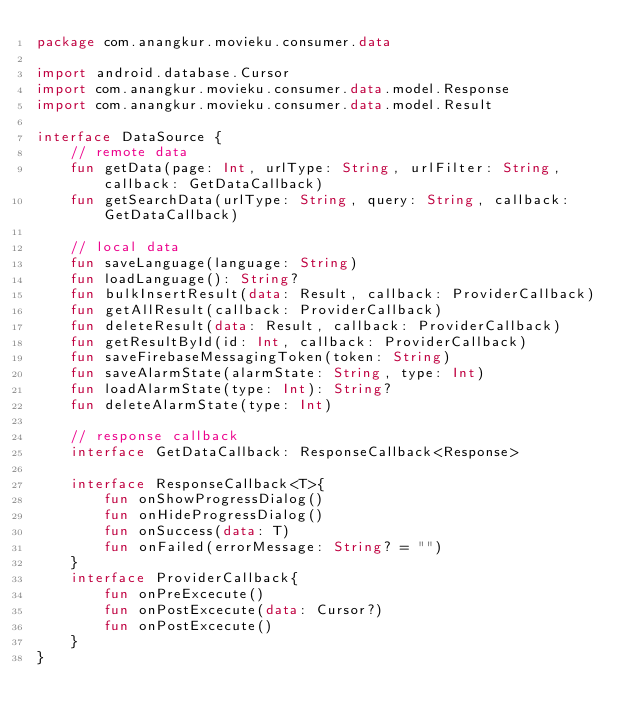Convert code to text. <code><loc_0><loc_0><loc_500><loc_500><_Kotlin_>package com.anangkur.movieku.consumer.data

import android.database.Cursor
import com.anangkur.movieku.consumer.data.model.Response
import com.anangkur.movieku.consumer.data.model.Result

interface DataSource {
    // remote data
    fun getData(page: Int, urlType: String, urlFilter: String, callback: GetDataCallback)
    fun getSearchData(urlType: String, query: String, callback: GetDataCallback)

    // local data
    fun saveLanguage(language: String)
    fun loadLanguage(): String?
    fun bulkInsertResult(data: Result, callback: ProviderCallback)
    fun getAllResult(callback: ProviderCallback)
    fun deleteResult(data: Result, callback: ProviderCallback)
    fun getResultById(id: Int, callback: ProviderCallback)
    fun saveFirebaseMessagingToken(token: String)
    fun saveAlarmState(alarmState: String, type: Int)
    fun loadAlarmState(type: Int): String?
    fun deleteAlarmState(type: Int)

    // response callback
    interface GetDataCallback: ResponseCallback<Response>

    interface ResponseCallback<T>{
        fun onShowProgressDialog()
        fun onHideProgressDialog()
        fun onSuccess(data: T)
        fun onFailed(errorMessage: String? = "")
    }
    interface ProviderCallback{
        fun onPreExcecute()
        fun onPostExcecute(data: Cursor?)
        fun onPostExcecute()
    }
}</code> 